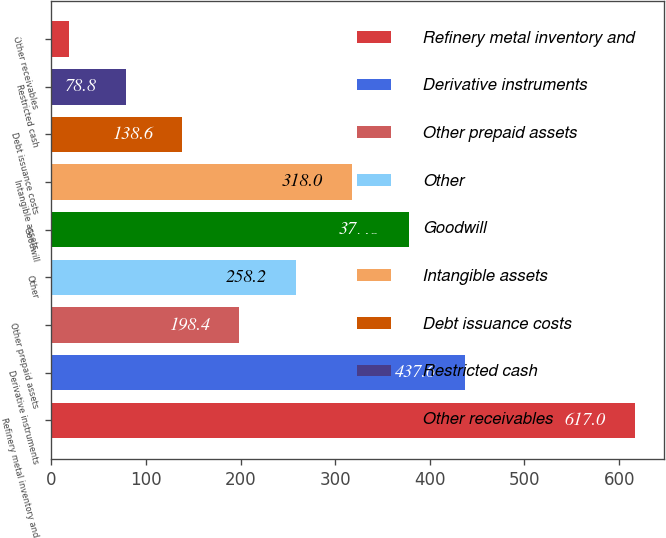<chart> <loc_0><loc_0><loc_500><loc_500><bar_chart><fcel>Refinery metal inventory and<fcel>Derivative instruments<fcel>Other prepaid assets<fcel>Other<fcel>Goodwill<fcel>Intangible assets<fcel>Debt issuance costs<fcel>Restricted cash<fcel>Other receivables<nl><fcel>617<fcel>437.6<fcel>198.4<fcel>258.2<fcel>377.8<fcel>318<fcel>138.6<fcel>78.8<fcel>19<nl></chart> 